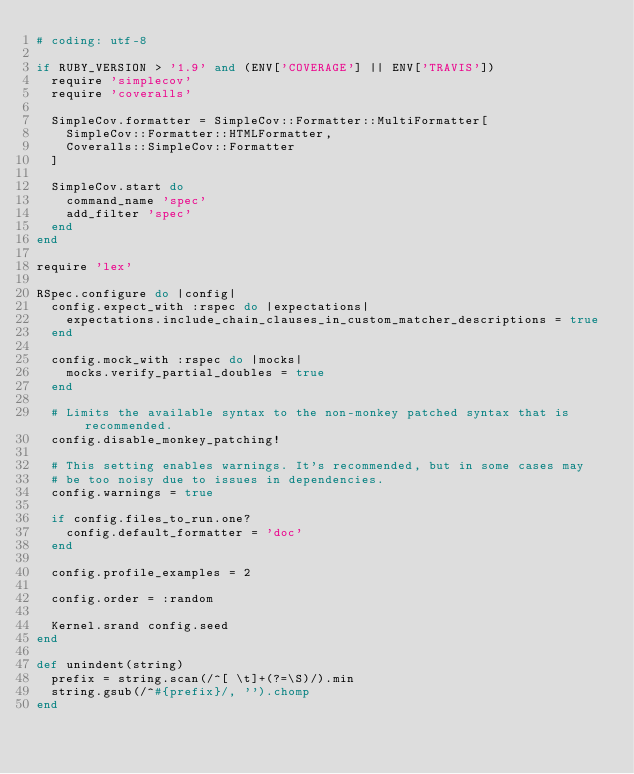<code> <loc_0><loc_0><loc_500><loc_500><_Ruby_># coding: utf-8

if RUBY_VERSION > '1.9' and (ENV['COVERAGE'] || ENV['TRAVIS'])
  require 'simplecov'
  require 'coveralls'

  SimpleCov.formatter = SimpleCov::Formatter::MultiFormatter[
    SimpleCov::Formatter::HTMLFormatter,
    Coveralls::SimpleCov::Formatter
  ]

  SimpleCov.start do
    command_name 'spec'
    add_filter 'spec'
  end
end

require 'lex'

RSpec.configure do |config|
  config.expect_with :rspec do |expectations|
    expectations.include_chain_clauses_in_custom_matcher_descriptions = true
  end

  config.mock_with :rspec do |mocks|
    mocks.verify_partial_doubles = true
  end

  # Limits the available syntax to the non-monkey patched syntax that is recommended.
  config.disable_monkey_patching!

  # This setting enables warnings. It's recommended, but in some cases may
  # be too noisy due to issues in dependencies.
  config.warnings = true

  if config.files_to_run.one?
    config.default_formatter = 'doc'
  end

  config.profile_examples = 2

  config.order = :random

  Kernel.srand config.seed
end

def unindent(string)
  prefix = string.scan(/^[ \t]+(?=\S)/).min
  string.gsub(/^#{prefix}/, '').chomp
end
</code> 